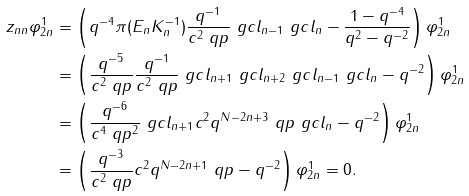<formula> <loc_0><loc_0><loc_500><loc_500>z _ { n n } \varphi ^ { 1 } _ { 2 n } & = \left ( q ^ { - 4 } \pi ( E _ { n } K _ { n } ^ { - 1 } ) \frac { q ^ { - 1 } } { c ^ { 2 } \ q p } \ g c l _ { n - 1 } \ g c l _ { n } - \frac { 1 - q ^ { - 4 } } { q ^ { 2 } - q ^ { - 2 } } \right ) \varphi ^ { 1 } _ { 2 n } \\ & = \left ( \frac { q ^ { - 5 } } { c ^ { 2 } \ q p } \frac { q ^ { - 1 } } { c ^ { 2 } \ q p } \ g c l _ { n + 1 } \ g c l _ { n + 2 } \ g c l _ { n - 1 } \ g c l _ { n } - q ^ { - 2 } \right ) \varphi ^ { 1 } _ { 2 n } \\ & = \left ( \frac { q ^ { - 6 } } { c ^ { 4 } \ q p ^ { 2 } } \ g c l _ { n + 1 } c ^ { 2 } q ^ { N - 2 n + 3 } \ q p \ g c l _ { n } - q ^ { - 2 } \right ) \varphi ^ { 1 } _ { 2 n } \\ & = \left ( \frac { q ^ { - 3 } } { c ^ { 2 } \ q p } c ^ { 2 } q ^ { N - 2 n + 1 } \ q p - q ^ { - 2 } \right ) \varphi ^ { 1 } _ { 2 n } = 0 .</formula> 